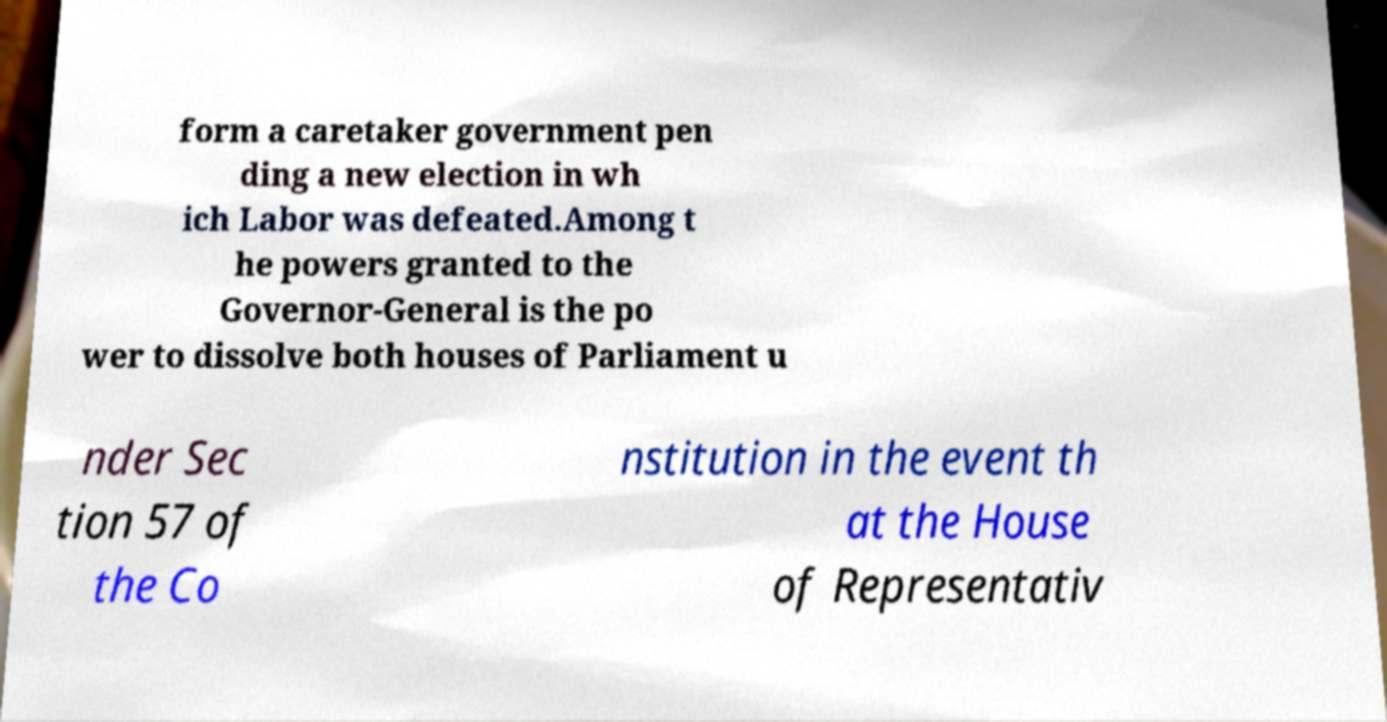Could you extract and type out the text from this image? form a caretaker government pen ding a new election in wh ich Labor was defeated.Among t he powers granted to the Governor-General is the po wer to dissolve both houses of Parliament u nder Sec tion 57 of the Co nstitution in the event th at the House of Representativ 